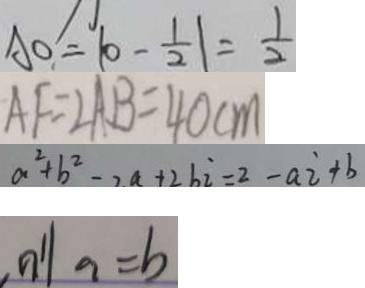<formula> <loc_0><loc_0><loc_500><loc_500>A O = \vert 0 - \frac { 1 } { 2 } \vert = \frac { 1 } { 2 } 
 A F = 2 A B = 4 0 c m 
 a ^ { 2 } + b ^ { 2 } = 2 a + 2 b i = 2 - a i + b 
 \vert n ^ { \prime } \vert a = b</formula> 